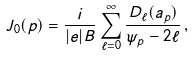<formula> <loc_0><loc_0><loc_500><loc_500>J _ { 0 } ( p ) = \frac { i } { | e | B } \sum _ { \ell = 0 } ^ { \infty } \frac { D _ { \ell } ( a _ { p } ) } { \psi _ { p } - 2 \ell } \, ,</formula> 